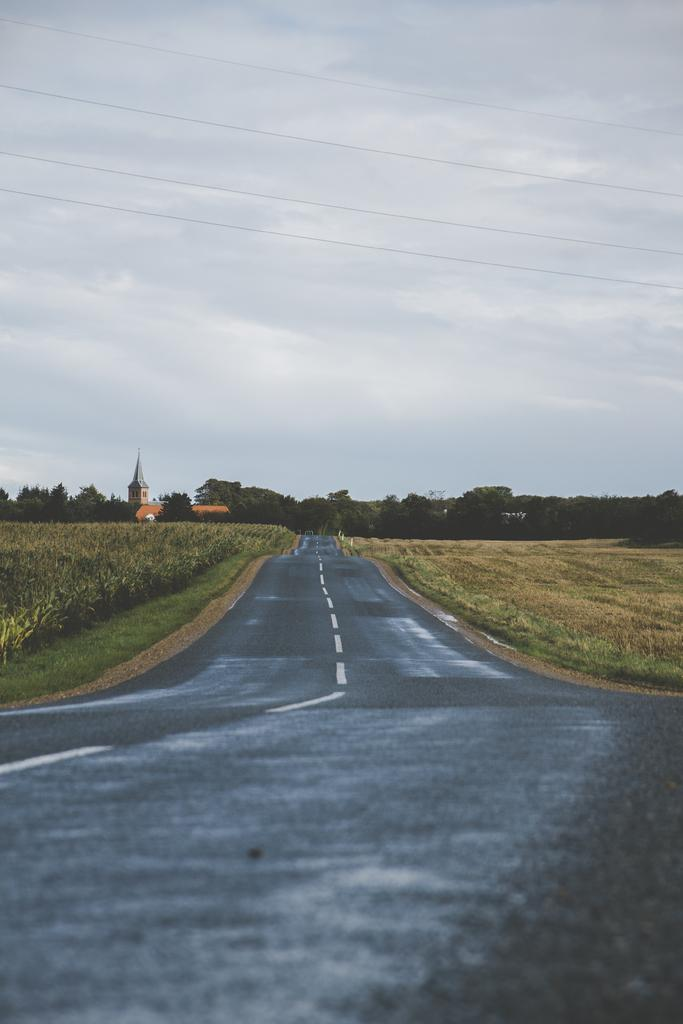What type of terrain is depicted in the image? There is a plain road in the image. What can be seen growing on either side of the road? There are crops on either side of the road. What is visible in the background of the image? There are plenty of trees in the background. How many houses are visible on the left side of the image? There are two houses on the left side of the image. What type of sound can be heard coming from the rabbit in the image? There is no rabbit present in the image, so it is not possible to determine what sound might be coming from it. 